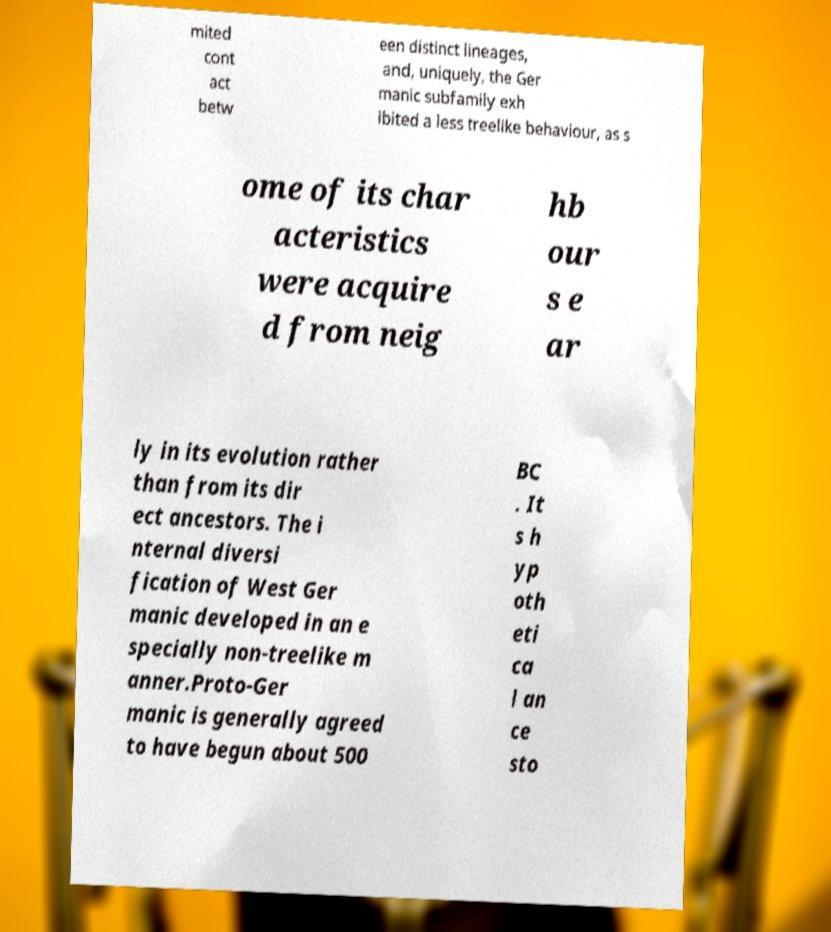Could you assist in decoding the text presented in this image and type it out clearly? mited cont act betw een distinct lineages, and, uniquely, the Ger manic subfamily exh ibited a less treelike behaviour, as s ome of its char acteristics were acquire d from neig hb our s e ar ly in its evolution rather than from its dir ect ancestors. The i nternal diversi fication of West Ger manic developed in an e specially non-treelike m anner.Proto-Ger manic is generally agreed to have begun about 500 BC . It s h yp oth eti ca l an ce sto 